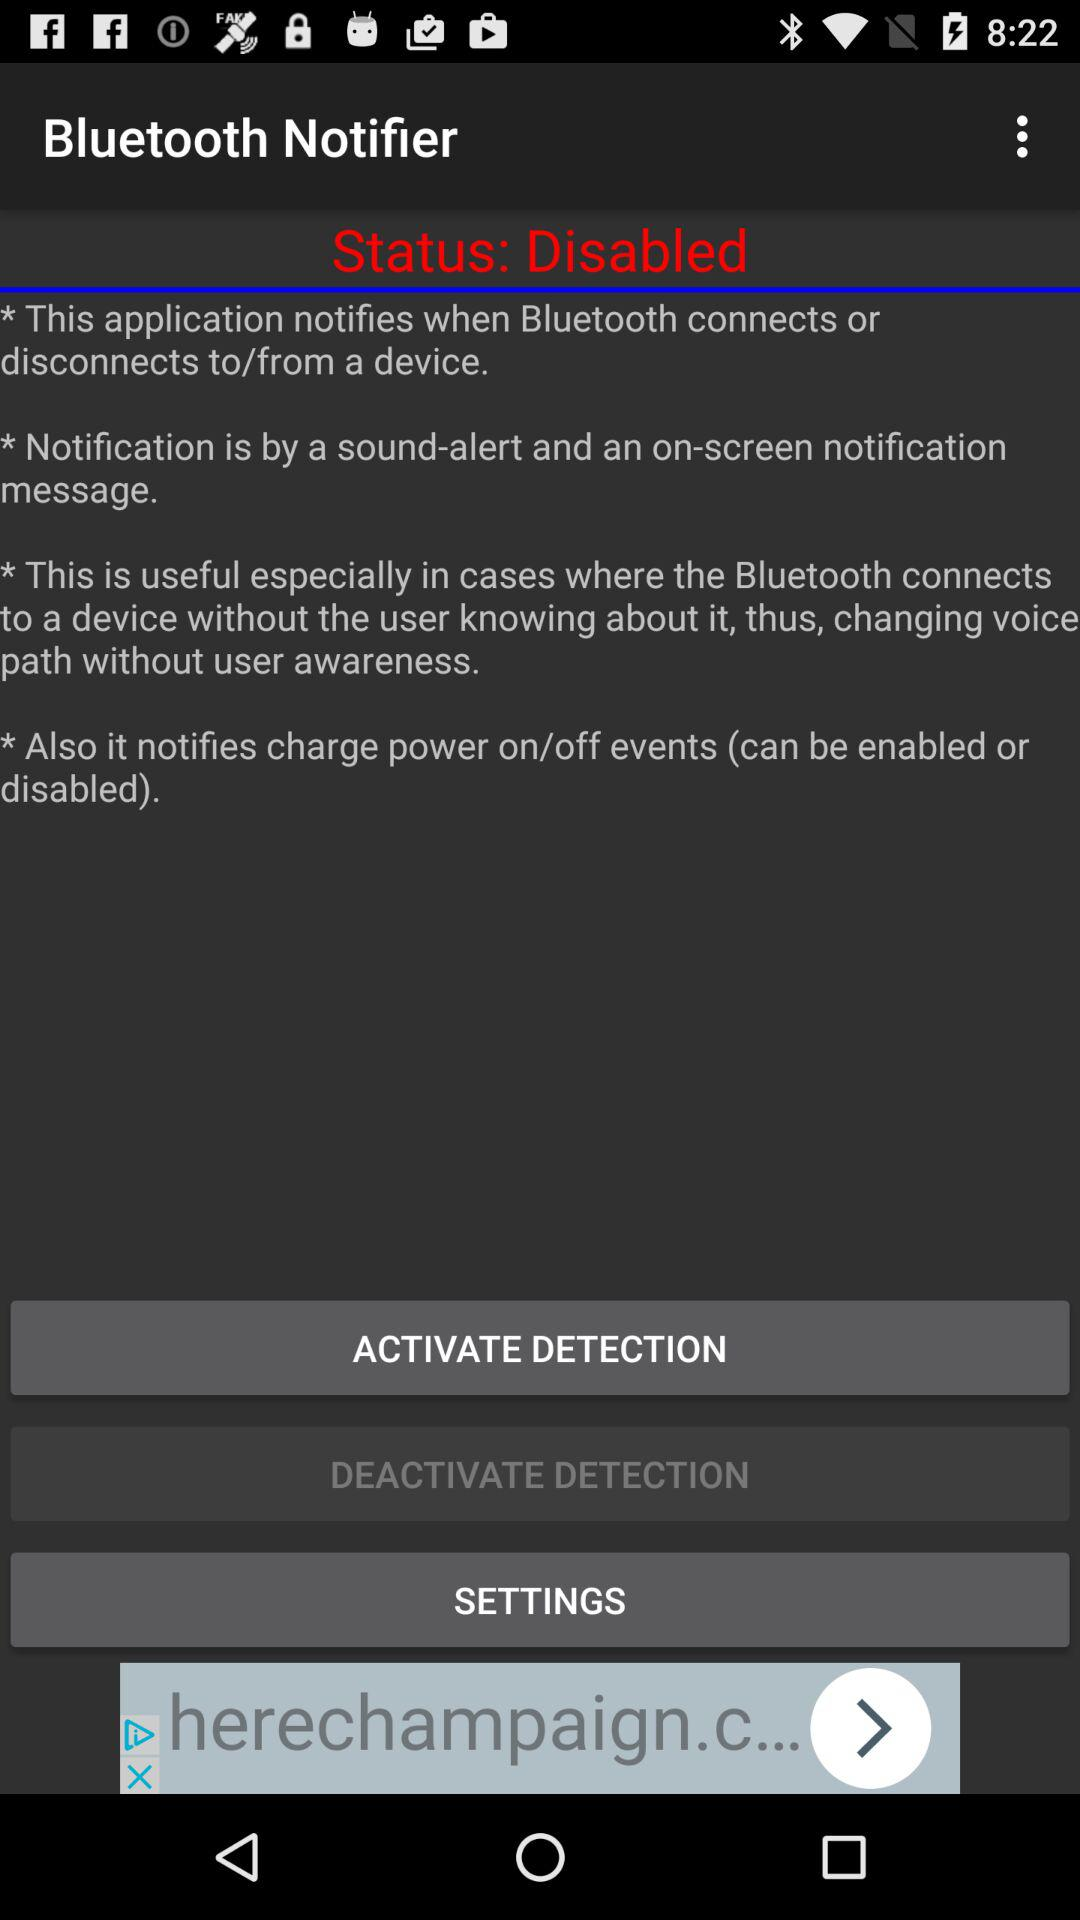Is the status enabled or disabled? The status is disabled. 